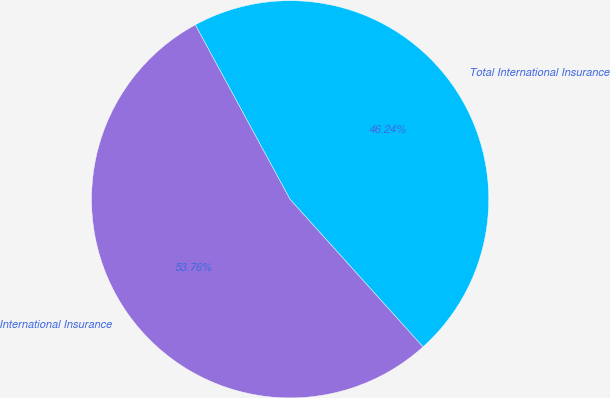<chart> <loc_0><loc_0><loc_500><loc_500><pie_chart><fcel>International Insurance<fcel>Total International Insurance<nl><fcel>53.76%<fcel>46.24%<nl></chart> 